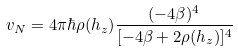<formula> <loc_0><loc_0><loc_500><loc_500>v _ { N } = 4 \pi \hbar { \rho } ( h _ { z } ) \frac { ( - 4 \beta ) ^ { 4 } } { [ - 4 \beta + 2 \rho ( h _ { z } ) ] ^ { 4 } }</formula> 